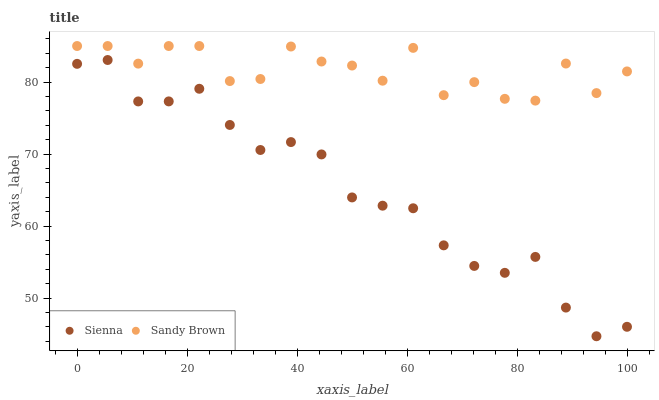Does Sienna have the minimum area under the curve?
Answer yes or no. Yes. Does Sandy Brown have the maximum area under the curve?
Answer yes or no. Yes. Does Sandy Brown have the minimum area under the curve?
Answer yes or no. No. Is Sienna the smoothest?
Answer yes or no. Yes. Is Sandy Brown the roughest?
Answer yes or no. Yes. Is Sandy Brown the smoothest?
Answer yes or no. No. Does Sienna have the lowest value?
Answer yes or no. Yes. Does Sandy Brown have the lowest value?
Answer yes or no. No. Does Sandy Brown have the highest value?
Answer yes or no. Yes. Is Sienna less than Sandy Brown?
Answer yes or no. Yes. Is Sandy Brown greater than Sienna?
Answer yes or no. Yes. Does Sienna intersect Sandy Brown?
Answer yes or no. No. 